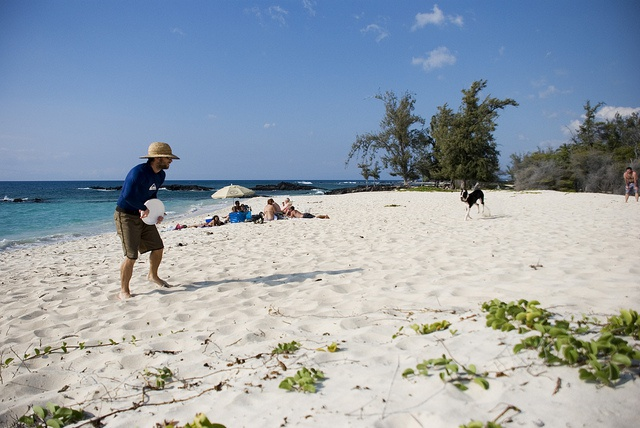Describe the objects in this image and their specific colors. I can see people in blue, black, darkgray, and maroon tones, dog in blue, black, lightgray, darkgray, and gray tones, umbrella in blue, darkgray, beige, gray, and lightgray tones, frisbee in blue, darkgray, lightgray, and gray tones, and people in blue, gray, brown, black, and maroon tones in this image. 